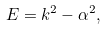<formula> <loc_0><loc_0><loc_500><loc_500>E = k ^ { 2 } - \alpha ^ { 2 } ,</formula> 